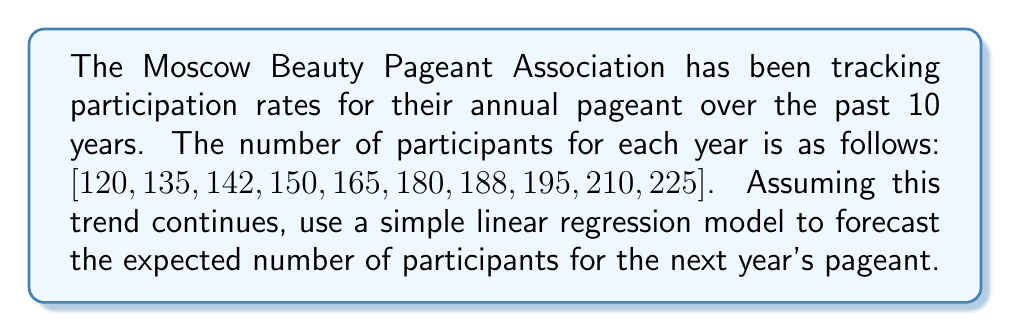Give your solution to this math problem. To forecast the future pageant participation rate using historical data, we'll use a simple linear regression model. Let's follow these steps:

1. Define variables:
   Let $x$ represent the year number (1 to 10) and $y$ represent the number of participants.

2. Calculate the means:
   $\bar{x} = \frac{1+2+3+...+10}{10} = 5.5$
   $\bar{y} = \frac{120+135+142+...+225}{10} = 171$

3. Calculate the slope (b) of the regression line:
   $$b = \frac{\sum_{i=1}^{n} (x_i - \bar{x})(y_i - \bar{y})}{\sum_{i=1}^{n} (x_i - \bar{x})^2}$$

   Numerator: $(1-5.5)(120-171) + (2-5.5)(135-171) + ... + (10-5.5)(225-171) = 3712.5$
   Denominator: $(1-5.5)^2 + (2-5.5)^2 + ... + (10-5.5)^2 = 82.5$

   $b = \frac{3712.5}{82.5} = 45$

4. Calculate the y-intercept (a):
   $a = \bar{y} - b\bar{x} = 171 - 45(5.5) = 123.5$

5. The linear regression equation is:
   $y = 45x + 123.5$

6. To forecast the next year's participation (year 11):
   $y = 45(11) + 123.5 = 618.5$

Therefore, the forecasted number of participants for the next year's pageant is approximately 619 (rounded to the nearest whole number).
Answer: 619 participants 